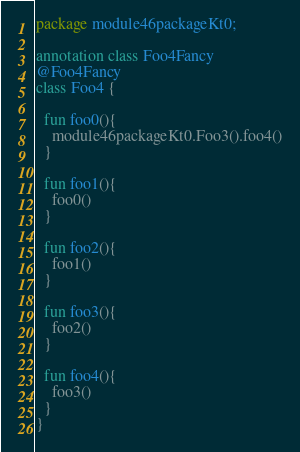<code> <loc_0><loc_0><loc_500><loc_500><_Kotlin_>package module46packageKt0;

annotation class Foo4Fancy
@Foo4Fancy
class Foo4 {

  fun foo0(){
    module46packageKt0.Foo3().foo4()
  }

  fun foo1(){
    foo0()
  }

  fun foo2(){
    foo1()
  }

  fun foo3(){
    foo2()
  }

  fun foo4(){
    foo3()
  }
}</code> 